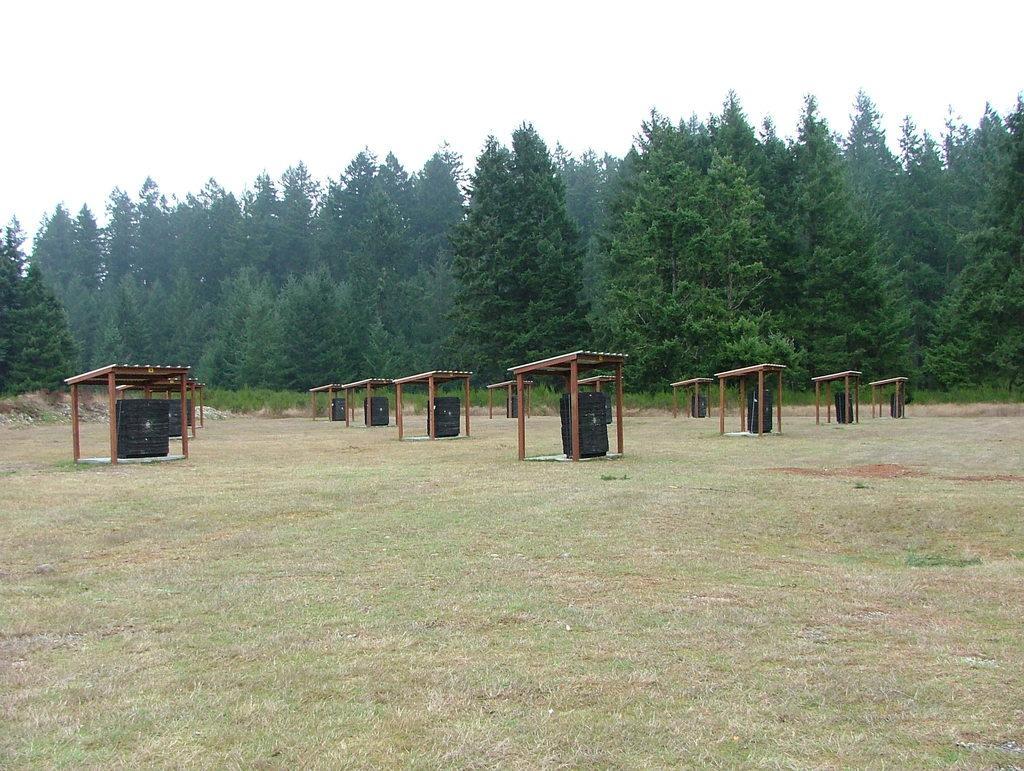Describe this image in one or two sentences. In the picture there is a ground, on the ground there are small sheds present, in the sheds there are black color objects present, there are trees, there is a clear sky. 